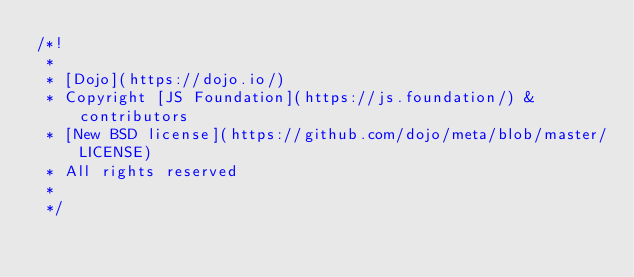Convert code to text. <code><loc_0><loc_0><loc_500><loc_500><_JavaScript_>/*!
 * 
 * [Dojo](https://dojo.io/)
 * Copyright [JS Foundation](https://js.foundation/) & contributors
 * [New BSD license](https://github.com/dojo/meta/blob/master/LICENSE)
 * All rights reserved
 * 
 */</code> 